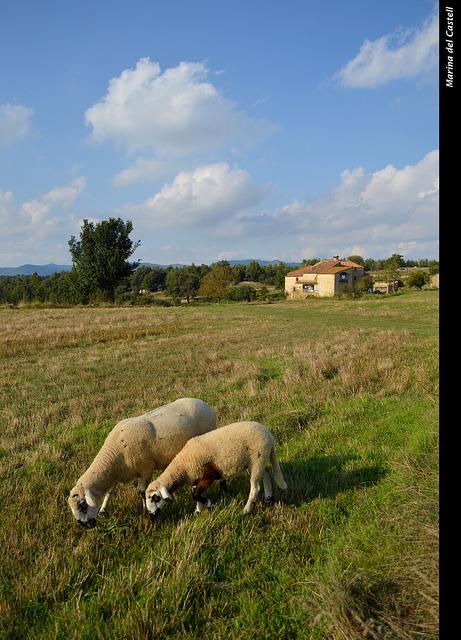Are the sheep hungry?
Answer briefly. Yes. Are the animals full grown?
Keep it brief. No. Has the sheep's tail been shortened?
Keep it brief. No. Are the sheep eating?
Keep it brief. Yes. Have these animals recently been shorn?
Quick response, please. Yes. How many sheep are there?
Keep it brief. 2. How many animals do you see?
Keep it brief. 2. Is the sky overcast in this picture?
Keep it brief. No. Is this animal in a zoo?
Be succinct. No. What type of animal is this?
Write a very short answer. Sheep. Are the animals on flat ground?
Write a very short answer. Yes. 